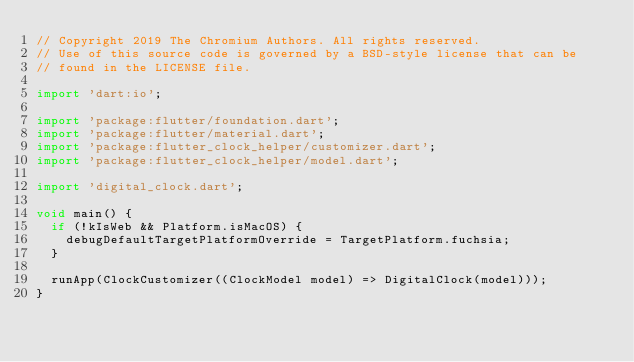<code> <loc_0><loc_0><loc_500><loc_500><_Dart_>// Copyright 2019 The Chromium Authors. All rights reserved.
// Use of this source code is governed by a BSD-style license that can be
// found in the LICENSE file.

import 'dart:io';

import 'package:flutter/foundation.dart';
import 'package:flutter/material.dart';
import 'package:flutter_clock_helper/customizer.dart';
import 'package:flutter_clock_helper/model.dart';

import 'digital_clock.dart';

void main() {
  if (!kIsWeb && Platform.isMacOS) {
    debugDefaultTargetPlatformOverride = TargetPlatform.fuchsia;
  }

  runApp(ClockCustomizer((ClockModel model) => DigitalClock(model)));
}
</code> 